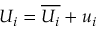Convert formula to latex. <formula><loc_0><loc_0><loc_500><loc_500>U _ { i } = \overline { { U _ { i } } } + u _ { i }</formula> 